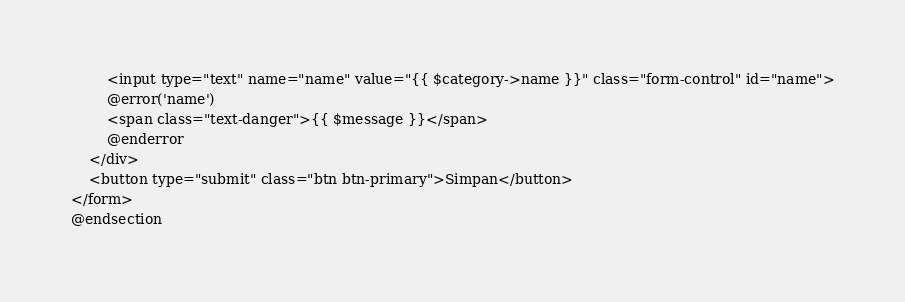<code> <loc_0><loc_0><loc_500><loc_500><_PHP_>        <input type="text" name="name" value="{{ $category->name }}" class="form-control" id="name">
        @error('name')
        <span class="text-danger">{{ $message }}</span>
        @enderror
    </div>
    <button type="submit" class="btn btn-primary">Simpan</button>
</form>
@endsection
</code> 